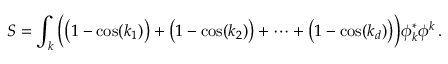Convert formula to latex. <formula><loc_0><loc_0><loc_500><loc_500>S = \int _ { k } { \left ( } { \left ( } 1 - \cos ( k _ { 1 } ) { \right ) } + { \left ( } 1 - \cos ( k _ { 2 } ) { \right ) } + \cdots + { \left ( } 1 - \cos ( k _ { d } ) { \right ) } { \right ) } \phi _ { k } ^ { * } \phi ^ { k } \, .</formula> 